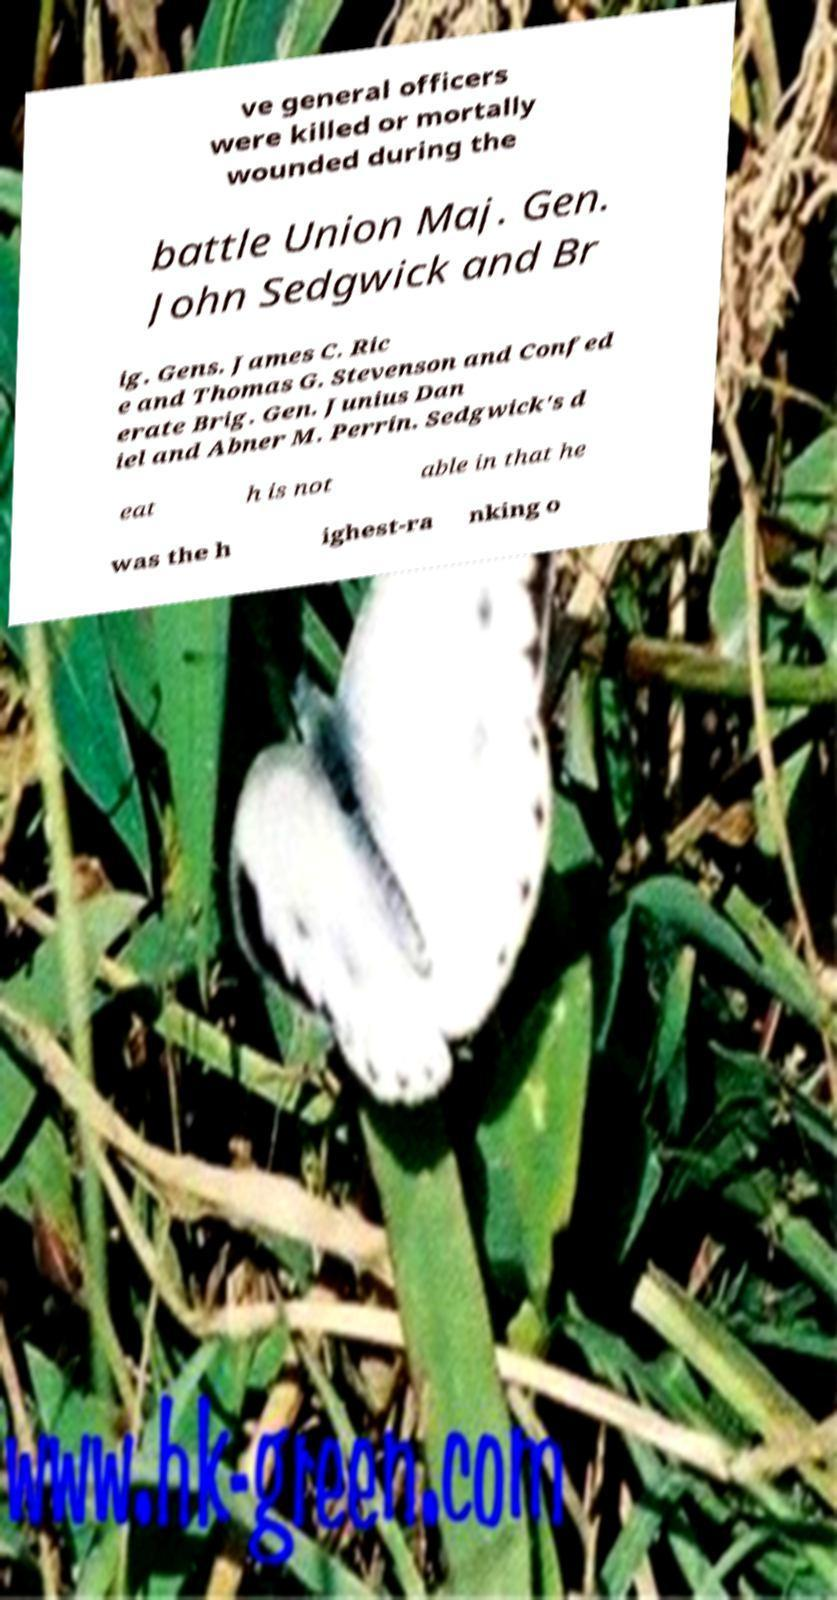Can you read and provide the text displayed in the image?This photo seems to have some interesting text. Can you extract and type it out for me? ve general officers were killed or mortally wounded during the battle Union Maj. Gen. John Sedgwick and Br ig. Gens. James C. Ric e and Thomas G. Stevenson and Confed erate Brig. Gen. Junius Dan iel and Abner M. Perrin. Sedgwick's d eat h is not able in that he was the h ighest-ra nking o 